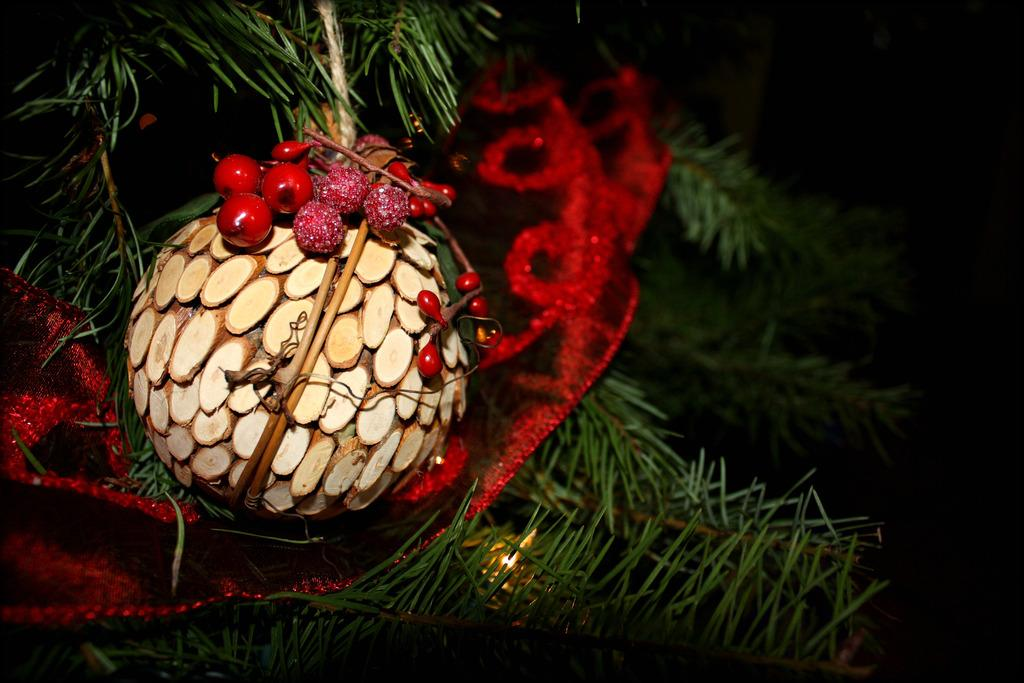What is the main subject of the image? There is a Christmas tree in the image. How is the Christmas tree decorated? The Christmas tree is decorated with decorative items. Where are the dolls placed in relation to the Christmas tree in the image? There are no dolls present in the image. 